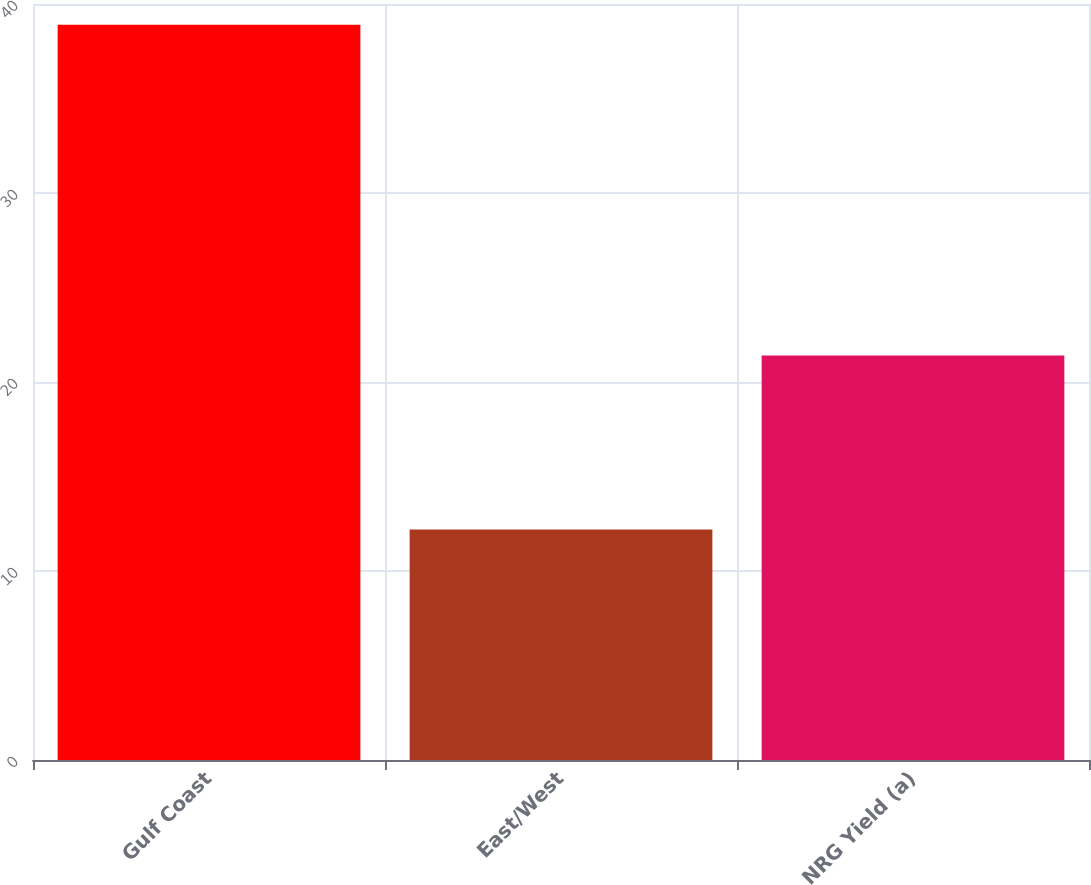Convert chart. <chart><loc_0><loc_0><loc_500><loc_500><bar_chart><fcel>Gulf Coast<fcel>East/West<fcel>NRG Yield (a)<nl><fcel>38.9<fcel>12.2<fcel>21.4<nl></chart> 